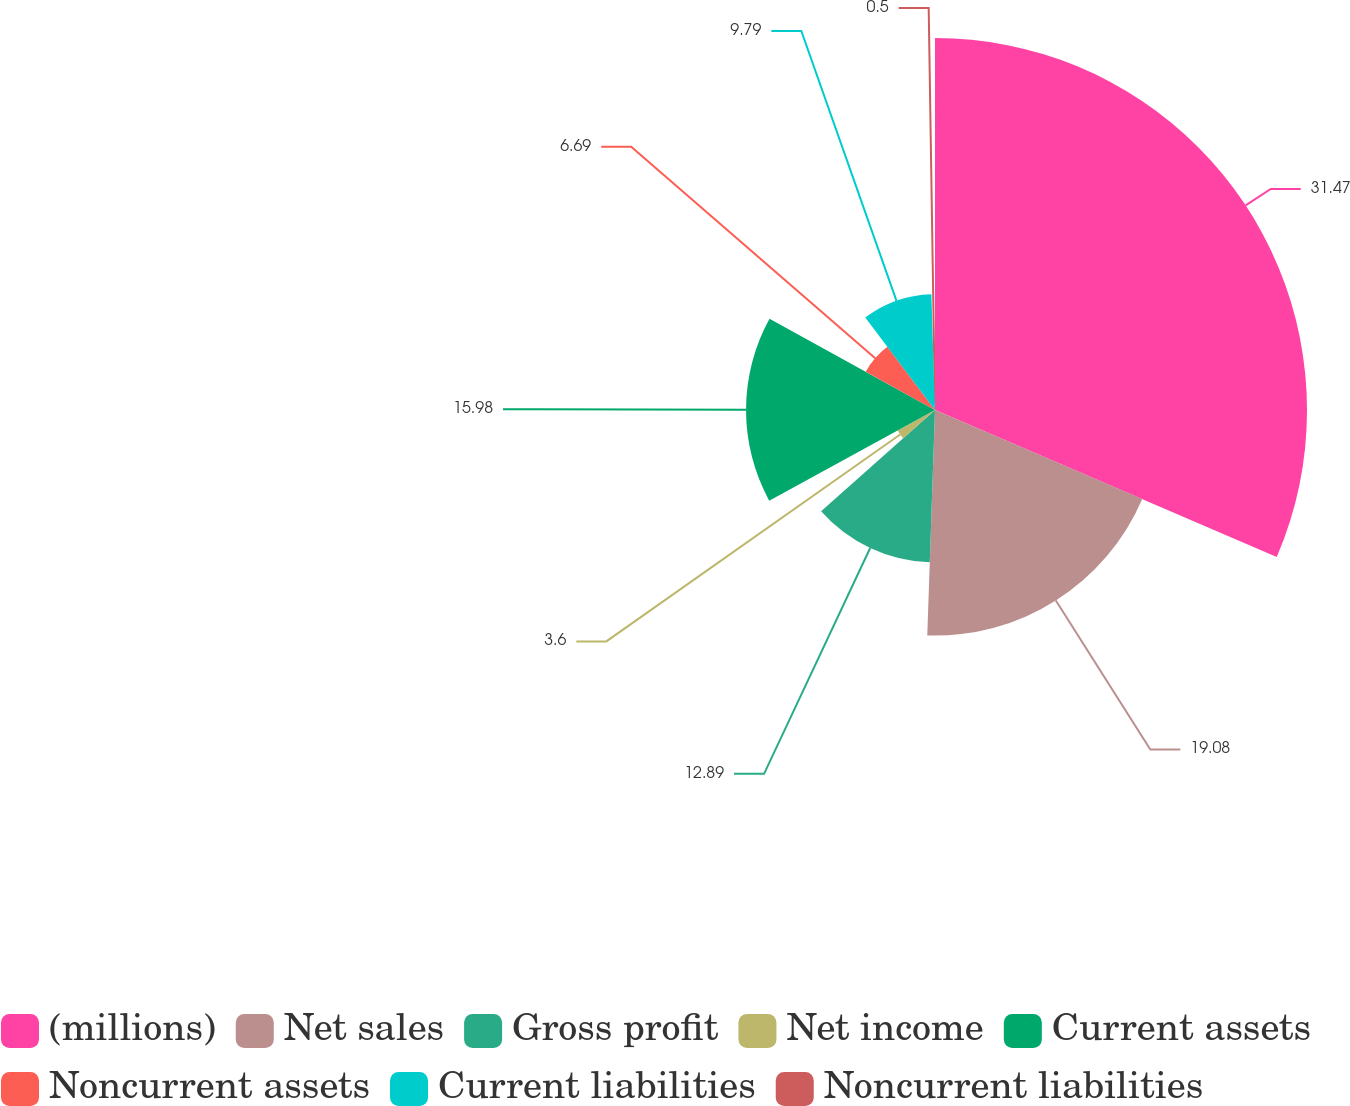<chart> <loc_0><loc_0><loc_500><loc_500><pie_chart><fcel>(millions)<fcel>Net sales<fcel>Gross profit<fcel>Net income<fcel>Current assets<fcel>Noncurrent assets<fcel>Current liabilities<fcel>Noncurrent liabilities<nl><fcel>31.46%<fcel>19.08%<fcel>12.89%<fcel>3.6%<fcel>15.98%<fcel>6.69%<fcel>9.79%<fcel>0.5%<nl></chart> 